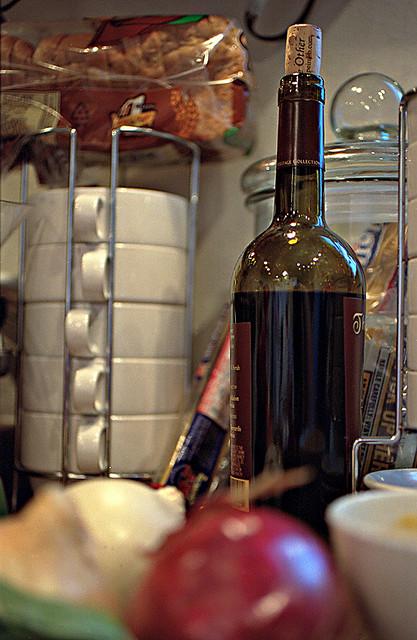How many coffee cups are in the rack?
Give a very brief answer. 5. Is this a bottle of wine?
Quick response, please. Yes. What is the red item in the foreground?
Be succinct. Apple. 